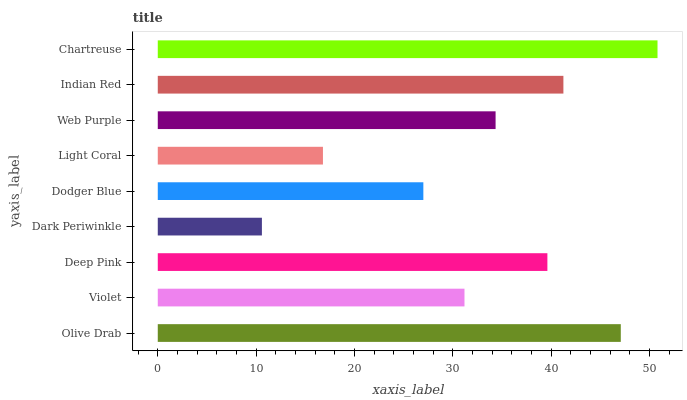Is Dark Periwinkle the minimum?
Answer yes or no. Yes. Is Chartreuse the maximum?
Answer yes or no. Yes. Is Violet the minimum?
Answer yes or no. No. Is Violet the maximum?
Answer yes or no. No. Is Olive Drab greater than Violet?
Answer yes or no. Yes. Is Violet less than Olive Drab?
Answer yes or no. Yes. Is Violet greater than Olive Drab?
Answer yes or no. No. Is Olive Drab less than Violet?
Answer yes or no. No. Is Web Purple the high median?
Answer yes or no. Yes. Is Web Purple the low median?
Answer yes or no. Yes. Is Light Coral the high median?
Answer yes or no. No. Is Olive Drab the low median?
Answer yes or no. No. 